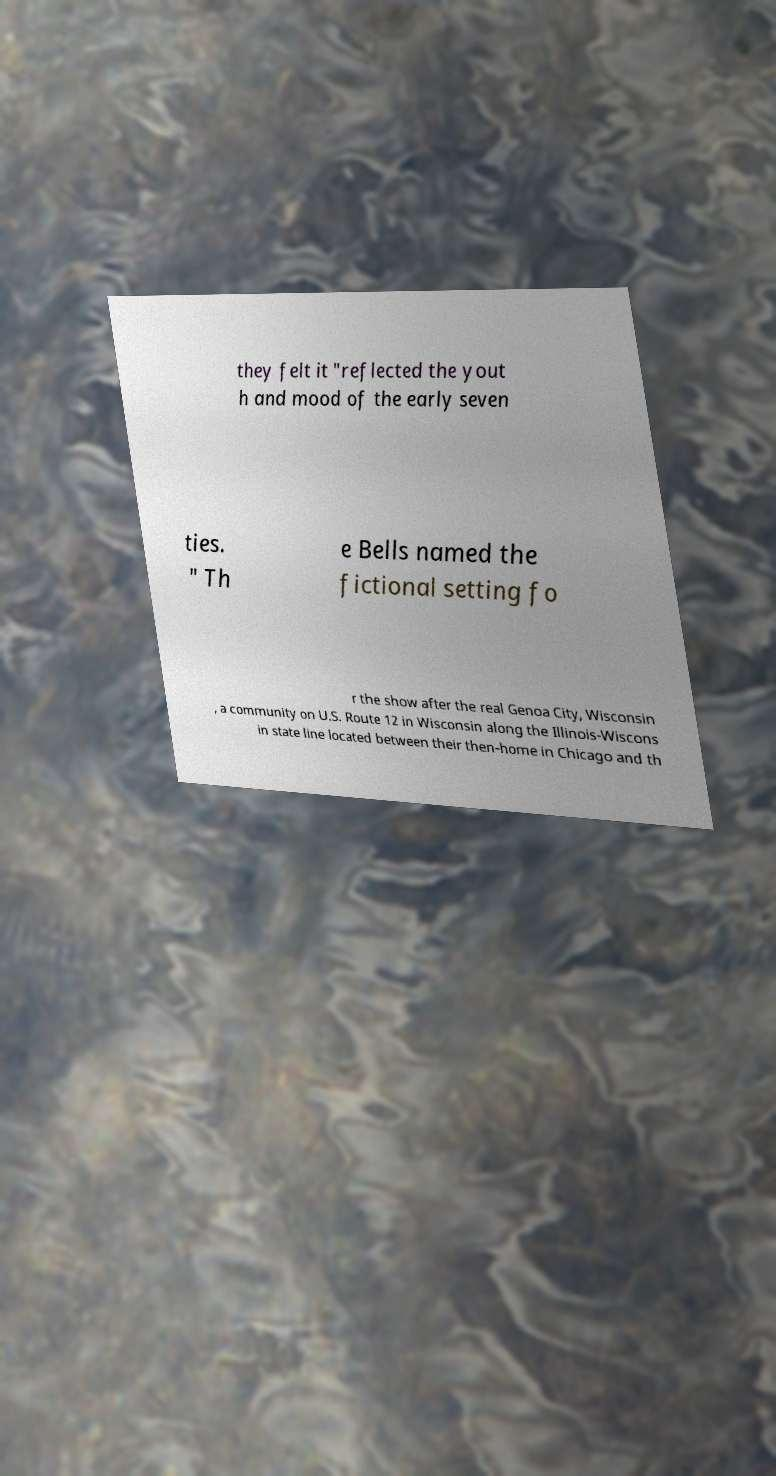Please read and relay the text visible in this image. What does it say? they felt it "reflected the yout h and mood of the early seven ties. " Th e Bells named the fictional setting fo r the show after the real Genoa City, Wisconsin , a community on U.S. Route 12 in Wisconsin along the Illinois-Wiscons in state line located between their then-home in Chicago and th 